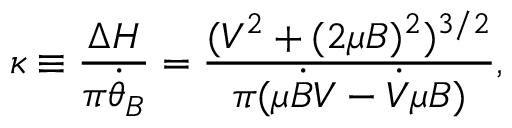Convert formula to latex. <formula><loc_0><loc_0><loc_500><loc_500>\kappa \equiv \frac { \Delta H } { \pi \dot { \theta } _ { B } } = \frac { ( V ^ { 2 } + ( 2 \mu B ) ^ { 2 } ) ^ { 3 / 2 } } { \pi ( \mu \dot { B } V - \dot { V } \mu B ) } ,</formula> 